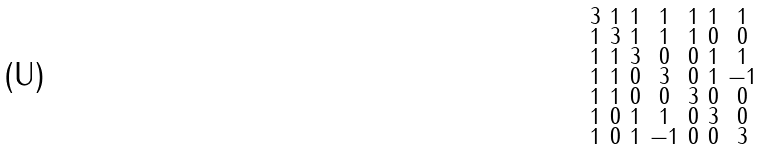Convert formula to latex. <formula><loc_0><loc_0><loc_500><loc_500>\begin{smallmatrix} 3 & 1 & 1 & 1 & 1 & 1 & 1 \\ 1 & 3 & 1 & 1 & 1 & 0 & 0 \\ 1 & 1 & 3 & 0 & 0 & 1 & 1 \\ 1 & 1 & 0 & 3 & 0 & 1 & - 1 \\ 1 & 1 & 0 & 0 & 3 & 0 & 0 \\ 1 & 0 & 1 & 1 & 0 & 3 & 0 \\ 1 & 0 & 1 & - 1 & 0 & 0 & 3 \end{smallmatrix}</formula> 